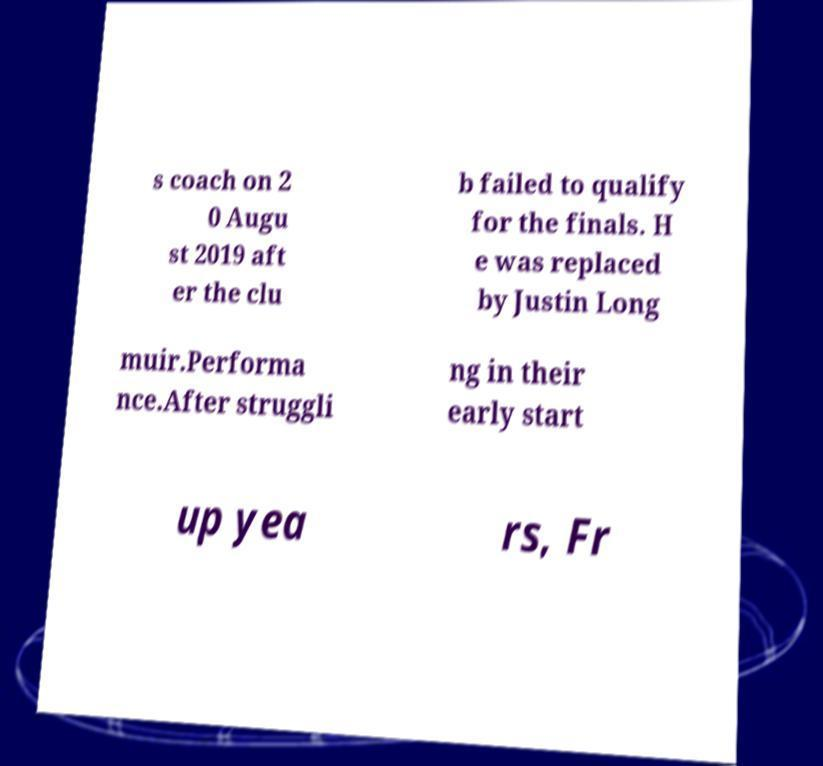I need the written content from this picture converted into text. Can you do that? s coach on 2 0 Augu st 2019 aft er the clu b failed to qualify for the finals. H e was replaced by Justin Long muir.Performa nce.After struggli ng in their early start up yea rs, Fr 